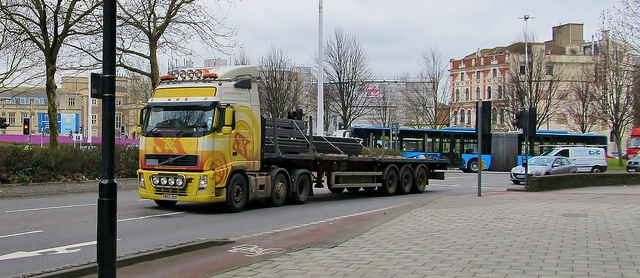Describe the objects in this image and their specific colors. I can see bus in brown, black, gray, darkgray, and navy tones, truck in brown, darkgray, black, and lightblue tones, car in brown, darkgray, and gray tones, traffic light in black, gray, and brown tones, and car in brown, black, darkgray, and gray tones in this image. 